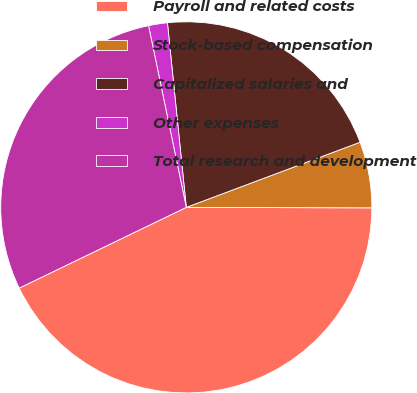Convert chart. <chart><loc_0><loc_0><loc_500><loc_500><pie_chart><fcel>Payroll and related costs<fcel>Stock-based compensation<fcel>Capitalized salaries and<fcel>Other expenses<fcel>Total research and development<nl><fcel>42.79%<fcel>5.75%<fcel>20.91%<fcel>1.64%<fcel>28.9%<nl></chart> 